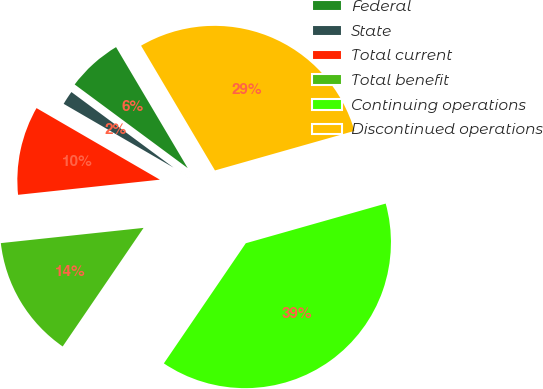Convert chart to OTSL. <chart><loc_0><loc_0><loc_500><loc_500><pie_chart><fcel>Federal<fcel>State<fcel>Total current<fcel>Total benefit<fcel>Continuing operations<fcel>Discontinued operations<nl><fcel>6.35%<fcel>1.77%<fcel>10.06%<fcel>13.78%<fcel>38.92%<fcel>29.11%<nl></chart> 